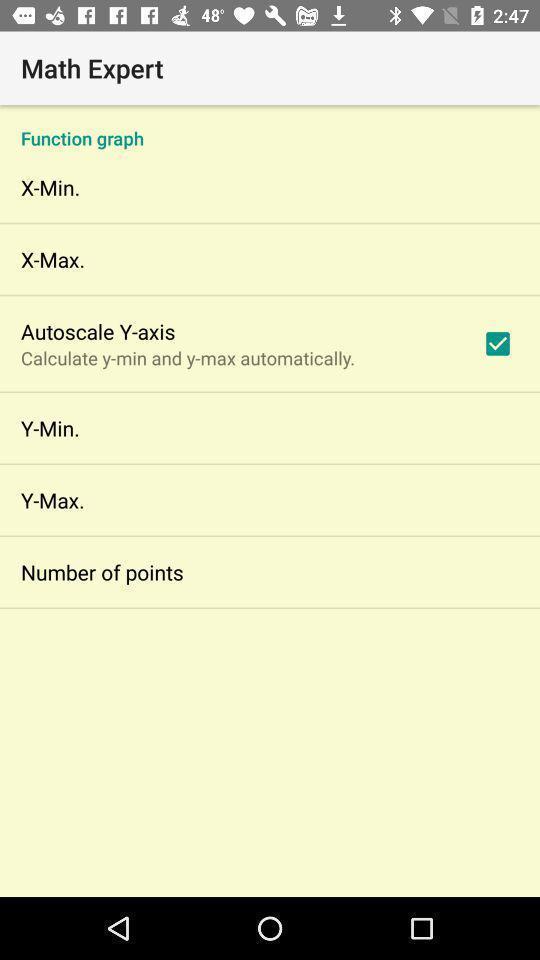Explain the elements present in this screenshot. Screen displaying the page of a calculation app. 